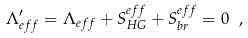<formula> <loc_0><loc_0><loc_500><loc_500>\Lambda _ { e f f } ^ { \prime } = \Lambda _ { e f f } + S _ { H G } ^ { e f f } + S _ { b r } ^ { e f f } = 0 \ ,</formula> 